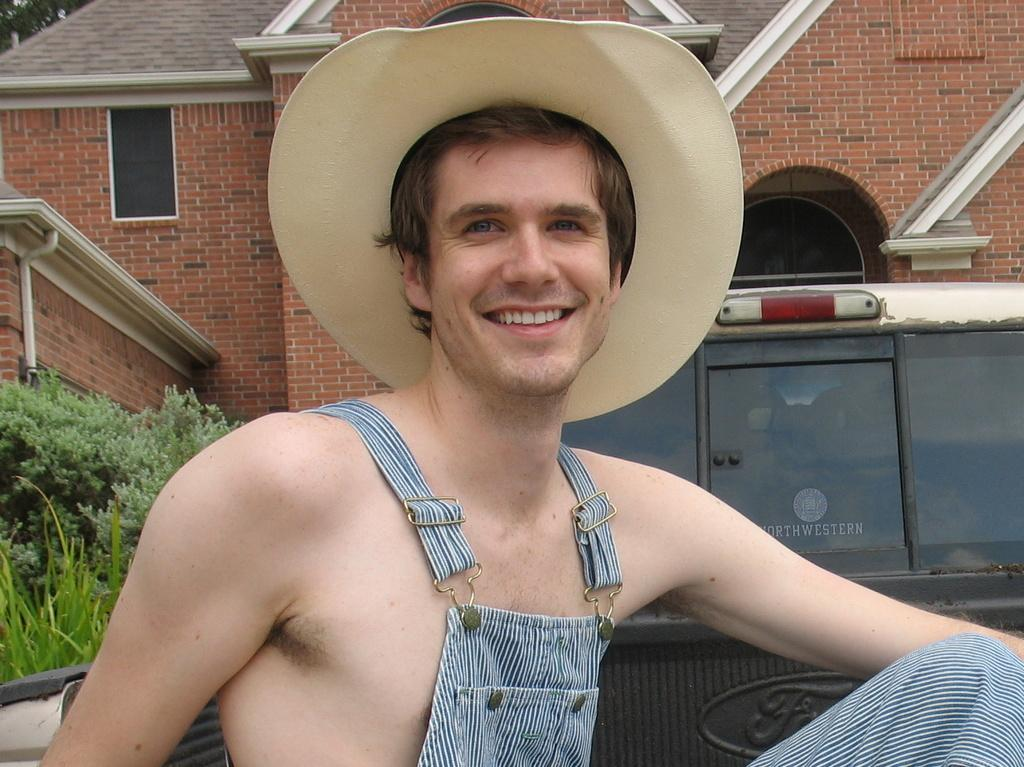What is the person in the image wearing on their head? The person in the image is wearing a hat. What type of structure can be seen in the image? There is a building in the image. What mode of transportation is present in the image? There is a vehicle in the image. What type of vegetation is visible in the image? There are plants in the image. What type of hill can be seen in the image? There is no hill present in the image. What religious belief does the person in the image follow? The image does not provide any information about the person's religious beliefs. What type of breakfast is being prepared in the image? There is no indication of breakfast or any food preparation in the image. 